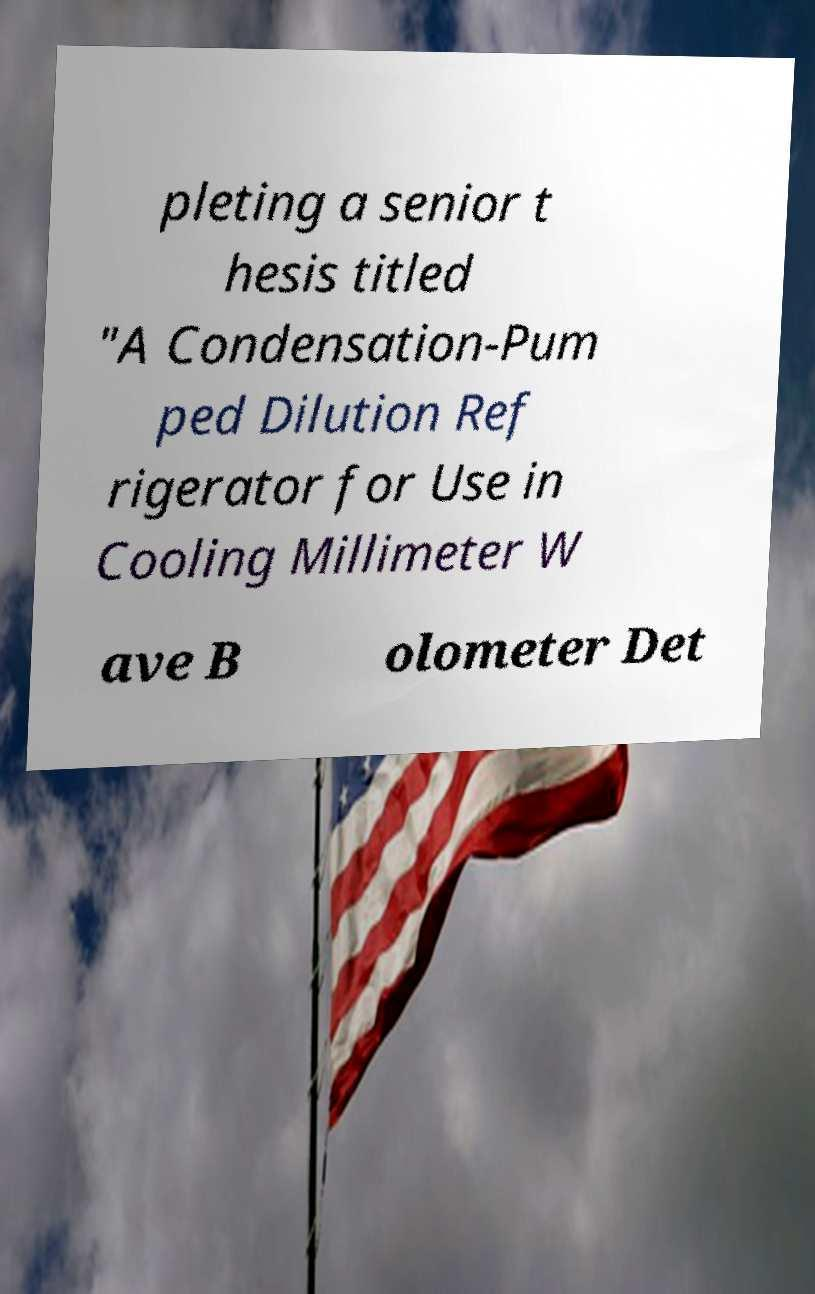There's text embedded in this image that I need extracted. Can you transcribe it verbatim? pleting a senior t hesis titled "A Condensation-Pum ped Dilution Ref rigerator for Use in Cooling Millimeter W ave B olometer Det 